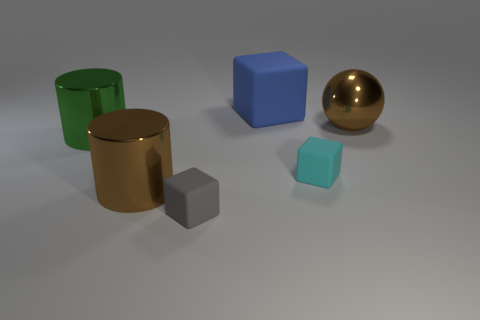Subtract all brown blocks. Subtract all red balls. How many blocks are left? 3 Subtract all cyan cubes. How many red spheres are left? 0 Add 5 big browns. How many large greens exist? 0 Subtract all green metallic cylinders. Subtract all cyan blocks. How many objects are left? 4 Add 4 metallic balls. How many metallic balls are left? 5 Add 1 tiny rubber objects. How many tiny rubber objects exist? 3 Add 3 green cylinders. How many objects exist? 9 Subtract all brown cylinders. How many cylinders are left? 1 Subtract all small cyan rubber cubes. How many cubes are left? 2 Subtract 0 green blocks. How many objects are left? 6 